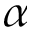<formula> <loc_0><loc_0><loc_500><loc_500>\alpha</formula> 